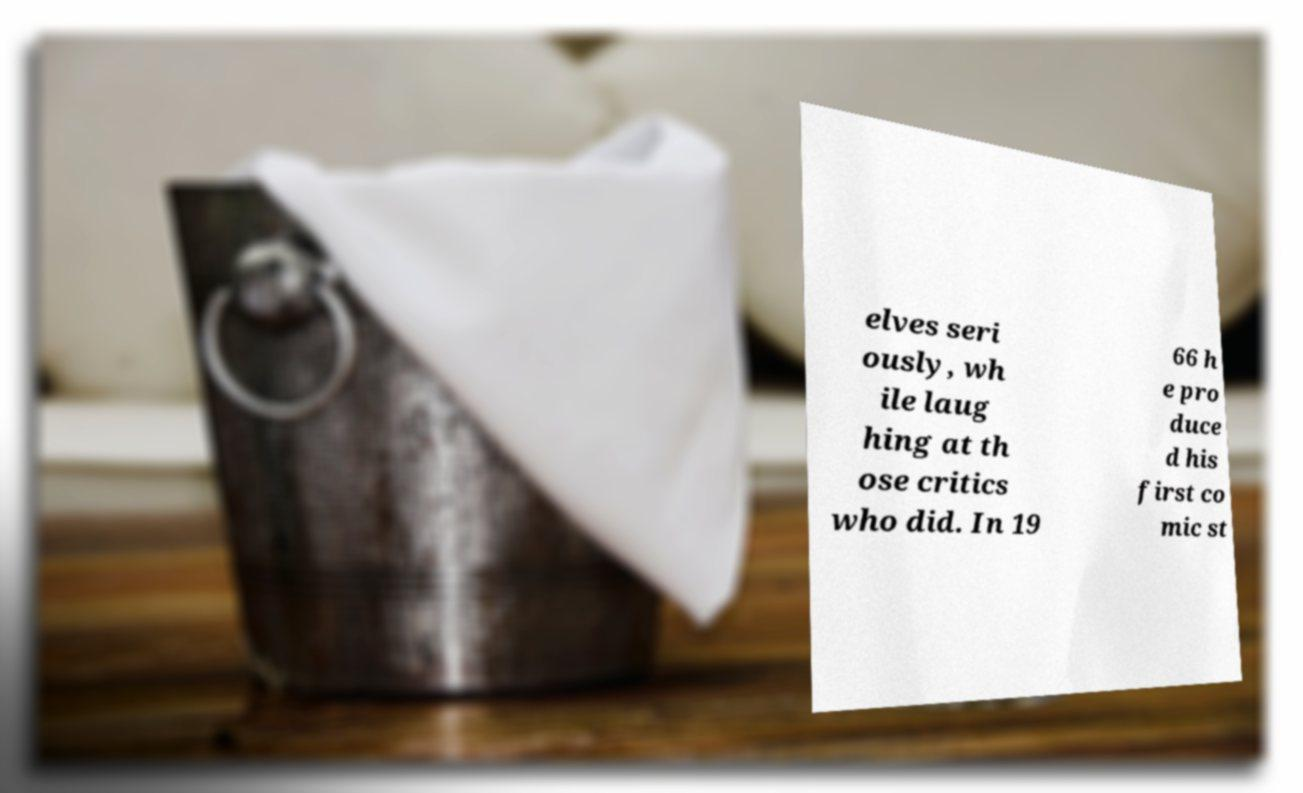What messages or text are displayed in this image? I need them in a readable, typed format. elves seri ously, wh ile laug hing at th ose critics who did. In 19 66 h e pro duce d his first co mic st 